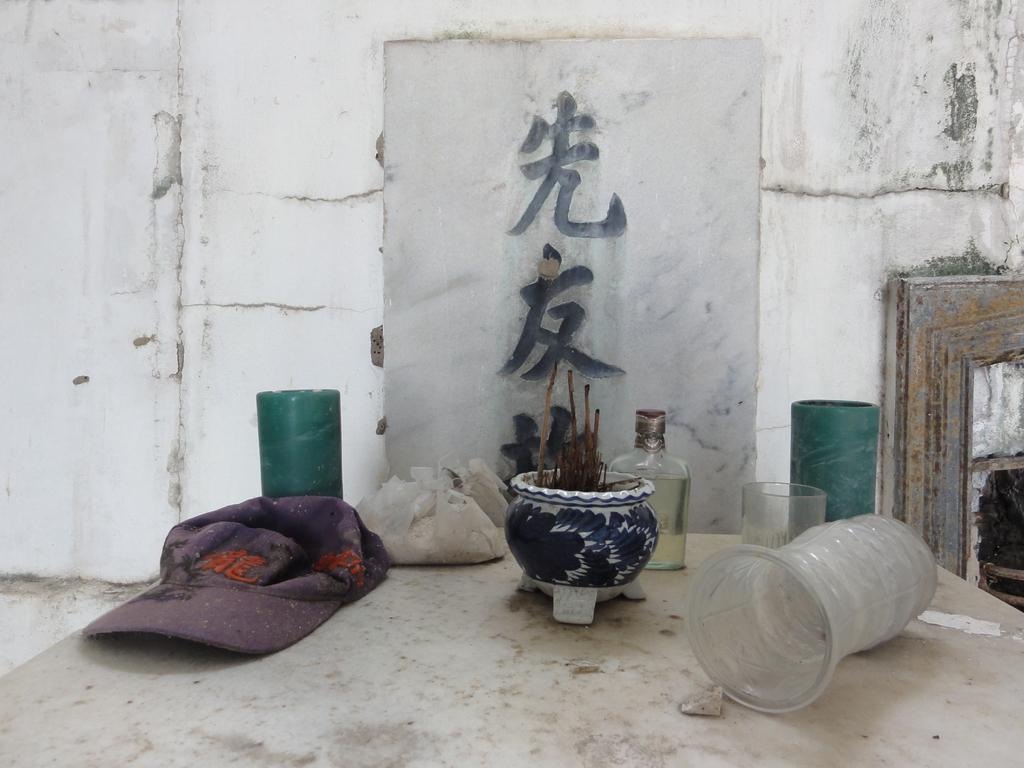Describe this image in one or two sentences. In this image there is a table towards the bottom of the image, there are objects on the table, at the background of the image there is a wall, there is text on the wall. 